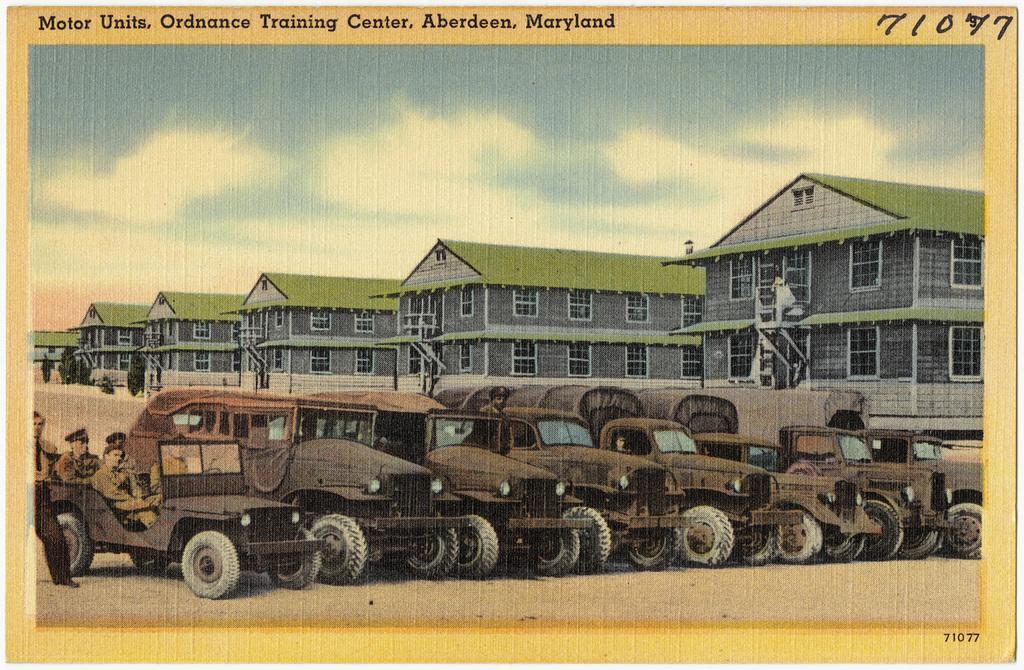Describe this image in one or two sentences. This image consists of a poster in which there are vehicles parked in a line. On the left, there are few persons. In the background, there are buildings along with windows and doors. At the top, there are clouds in the sky. 